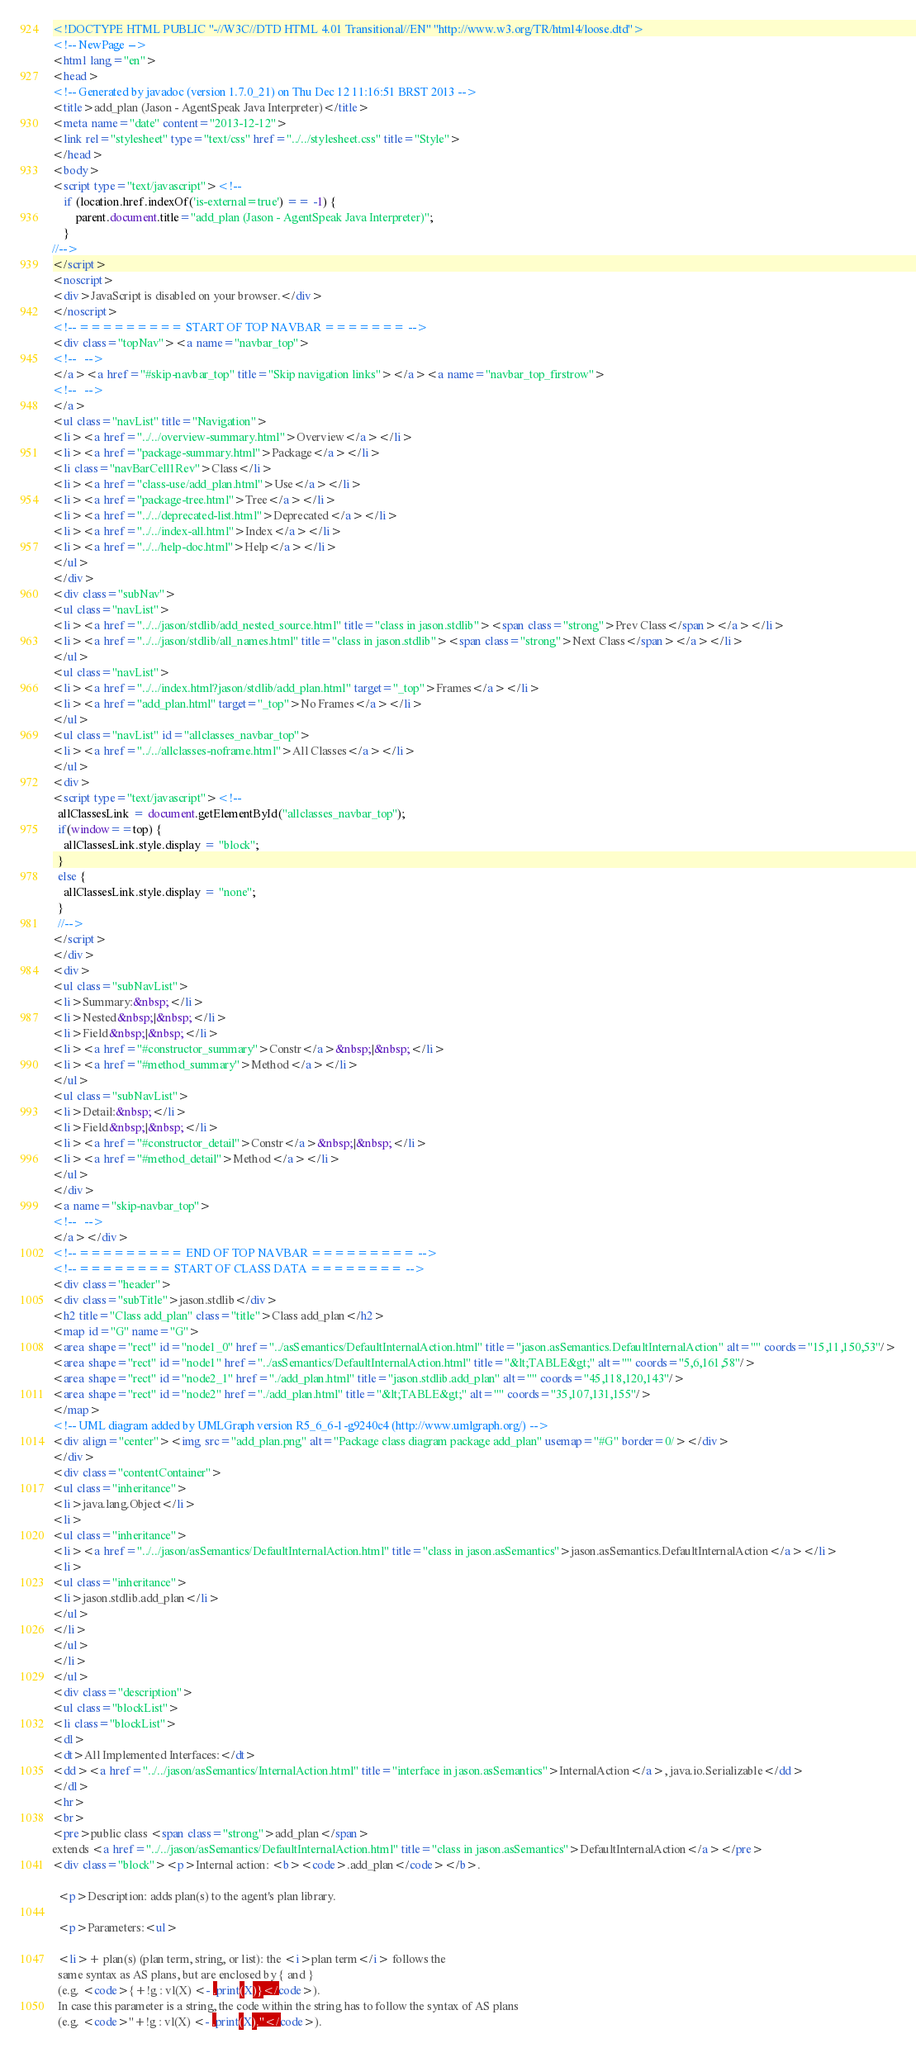<code> <loc_0><loc_0><loc_500><loc_500><_HTML_><!DOCTYPE HTML PUBLIC "-//W3C//DTD HTML 4.01 Transitional//EN" "http://www.w3.org/TR/html4/loose.dtd">
<!-- NewPage -->
<html lang="en">
<head>
<!-- Generated by javadoc (version 1.7.0_21) on Thu Dec 12 11:16:51 BRST 2013 -->
<title>add_plan (Jason - AgentSpeak Java Interpreter)</title>
<meta name="date" content="2013-12-12">
<link rel="stylesheet" type="text/css" href="../../stylesheet.css" title="Style">
</head>
<body>
<script type="text/javascript"><!--
    if (location.href.indexOf('is-external=true') == -1) {
        parent.document.title="add_plan (Jason - AgentSpeak Java Interpreter)";
    }
//-->
</script>
<noscript>
<div>JavaScript is disabled on your browser.</div>
</noscript>
<!-- ========= START OF TOP NAVBAR ======= -->
<div class="topNav"><a name="navbar_top">
<!--   -->
</a><a href="#skip-navbar_top" title="Skip navigation links"></a><a name="navbar_top_firstrow">
<!--   -->
</a>
<ul class="navList" title="Navigation">
<li><a href="../../overview-summary.html">Overview</a></li>
<li><a href="package-summary.html">Package</a></li>
<li class="navBarCell1Rev">Class</li>
<li><a href="class-use/add_plan.html">Use</a></li>
<li><a href="package-tree.html">Tree</a></li>
<li><a href="../../deprecated-list.html">Deprecated</a></li>
<li><a href="../../index-all.html">Index</a></li>
<li><a href="../../help-doc.html">Help</a></li>
</ul>
</div>
<div class="subNav">
<ul class="navList">
<li><a href="../../jason/stdlib/add_nested_source.html" title="class in jason.stdlib"><span class="strong">Prev Class</span></a></li>
<li><a href="../../jason/stdlib/all_names.html" title="class in jason.stdlib"><span class="strong">Next Class</span></a></li>
</ul>
<ul class="navList">
<li><a href="../../index.html?jason/stdlib/add_plan.html" target="_top">Frames</a></li>
<li><a href="add_plan.html" target="_top">No Frames</a></li>
</ul>
<ul class="navList" id="allclasses_navbar_top">
<li><a href="../../allclasses-noframe.html">All Classes</a></li>
</ul>
<div>
<script type="text/javascript"><!--
  allClassesLink = document.getElementById("allclasses_navbar_top");
  if(window==top) {
    allClassesLink.style.display = "block";
  }
  else {
    allClassesLink.style.display = "none";
  }
  //-->
</script>
</div>
<div>
<ul class="subNavList">
<li>Summary:&nbsp;</li>
<li>Nested&nbsp;|&nbsp;</li>
<li>Field&nbsp;|&nbsp;</li>
<li><a href="#constructor_summary">Constr</a>&nbsp;|&nbsp;</li>
<li><a href="#method_summary">Method</a></li>
</ul>
<ul class="subNavList">
<li>Detail:&nbsp;</li>
<li>Field&nbsp;|&nbsp;</li>
<li><a href="#constructor_detail">Constr</a>&nbsp;|&nbsp;</li>
<li><a href="#method_detail">Method</a></li>
</ul>
</div>
<a name="skip-navbar_top">
<!--   -->
</a></div>
<!-- ========= END OF TOP NAVBAR ========= -->
<!-- ======== START OF CLASS DATA ======== -->
<div class="header">
<div class="subTitle">jason.stdlib</div>
<h2 title="Class add_plan" class="title">Class add_plan</h2>
<map id="G" name="G">
<area shape="rect" id="node1_0" href="../asSemantics/DefaultInternalAction.html" title="jason.asSemantics.DefaultInternalAction" alt="" coords="15,11,150,53"/>
<area shape="rect" id="node1" href="../asSemantics/DefaultInternalAction.html" title="&lt;TABLE&gt;" alt="" coords="5,6,161,58"/>
<area shape="rect" id="node2_1" href="./add_plan.html" title="jason.stdlib.add_plan" alt="" coords="45,118,120,143"/>
<area shape="rect" id="node2" href="./add_plan.html" title="&lt;TABLE&gt;" alt="" coords="35,107,131,155"/>
</map>
<!-- UML diagram added by UMLGraph version R5_6_6-1-g9240c4 (http://www.umlgraph.org/) -->
<div align="center"><img src="add_plan.png" alt="Package class diagram package add_plan" usemap="#G" border=0/></div>
</div>
<div class="contentContainer">
<ul class="inheritance">
<li>java.lang.Object</li>
<li>
<ul class="inheritance">
<li><a href="../../jason/asSemantics/DefaultInternalAction.html" title="class in jason.asSemantics">jason.asSemantics.DefaultInternalAction</a></li>
<li>
<ul class="inheritance">
<li>jason.stdlib.add_plan</li>
</ul>
</li>
</ul>
</li>
</ul>
<div class="description">
<ul class="blockList">
<li class="blockList">
<dl>
<dt>All Implemented Interfaces:</dt>
<dd><a href="../../jason/asSemantics/InternalAction.html" title="interface in jason.asSemantics">InternalAction</a>, java.io.Serializable</dd>
</dl>
<hr>
<br>
<pre>public class <span class="strong">add_plan</span>
extends <a href="../../jason/asSemantics/DefaultInternalAction.html" title="class in jason.asSemantics">DefaultInternalAction</a></pre>
<div class="block"><p>Internal action: <b><code>.add_plan</code></b>.

  <p>Description: adds plan(s) to the agent's plan library.

  <p>Parameters:<ul>

  <li>+ plan(s) (plan term, string, or list): the <i>plan term</i> follows the
  same syntax as AS plans, but are enclosed by { and } 
  (e.g. <code>{+!g : vl(X) <- .print(X)}</code>). 
  In case this parameter is a string, the code within the string has to follow the syntax of AS plans
  (e.g. <code>"+!g : vl(X) <- .print(X)."</code>). </code> 